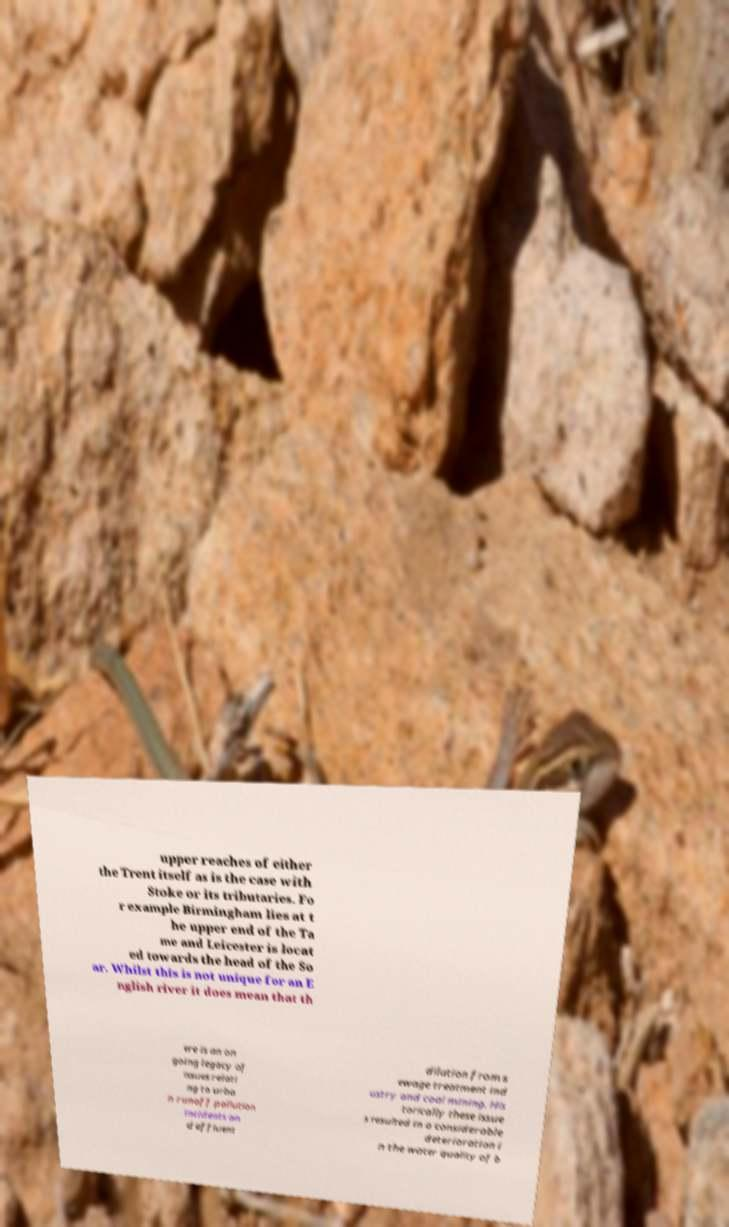Can you read and provide the text displayed in the image?This photo seems to have some interesting text. Can you extract and type it out for me? upper reaches of either the Trent itself as is the case with Stoke or its tributaries. Fo r example Birmingham lies at t he upper end of the Ta me and Leicester is locat ed towards the head of the So ar. Whilst this is not unique for an E nglish river it does mean that th ere is an on going legacy of issues relati ng to urba n runoff pollution incidents an d effluent dilution from s ewage treatment ind ustry and coal mining. His torically these issue s resulted in a considerable deterioration i n the water quality of b 